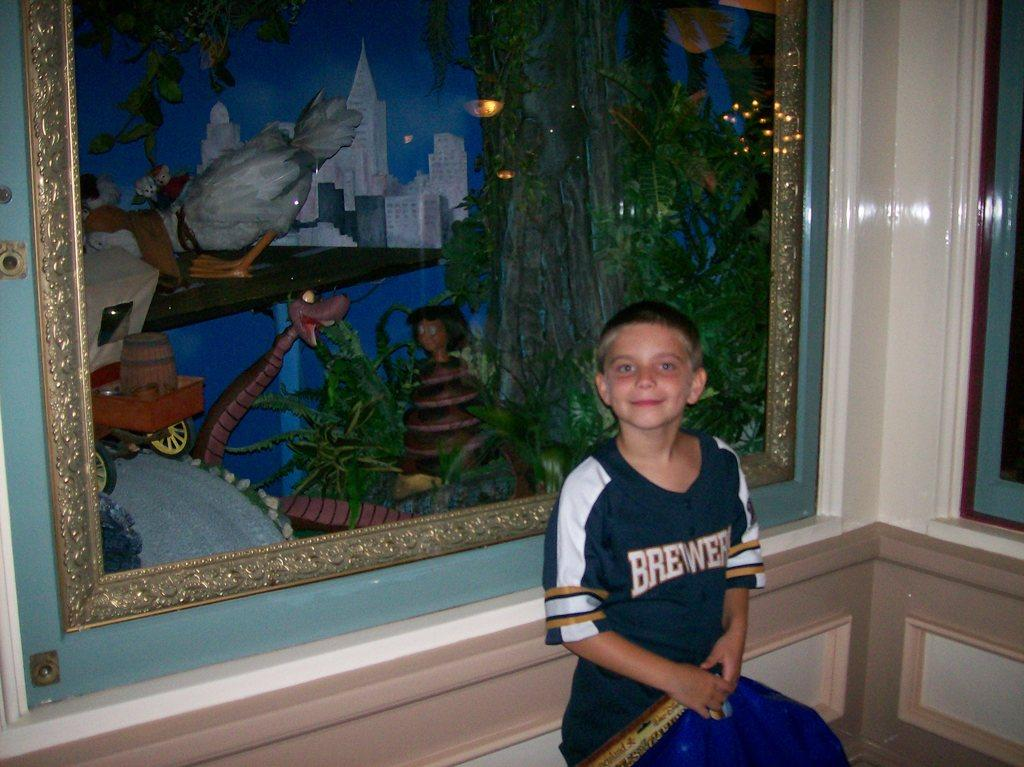<image>
Offer a succinct explanation of the picture presented. a lillte boy wearing a brewers shirt in front of a painting 